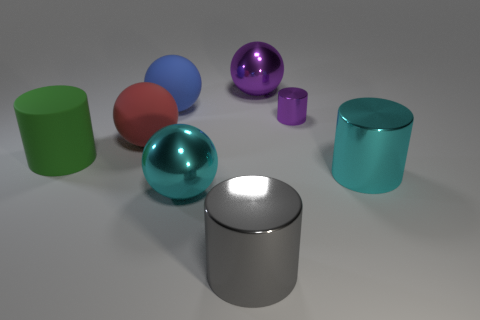Is the number of large red matte things that are in front of the large blue matte object the same as the number of purple metal objects in front of the large purple shiny sphere?
Ensure brevity in your answer.  Yes. Is there any other thing that has the same size as the purple metal cylinder?
Keep it short and to the point. No. What is the material of the other tiny object that is the same shape as the green object?
Your answer should be very brief. Metal. There is a object in front of the shiny sphere that is in front of the purple shiny sphere; are there any big matte objects that are on the left side of it?
Ensure brevity in your answer.  Yes. Do the big cyan thing left of the gray cylinder and the large metallic thing behind the large cyan cylinder have the same shape?
Provide a short and direct response. Yes. Are there more cyan metallic things left of the tiny purple thing than brown rubber cylinders?
Provide a succinct answer. Yes. How many objects are tiny purple rubber balls or large gray cylinders?
Offer a terse response. 1. The matte cylinder has what color?
Your answer should be very brief. Green. How many other objects are there of the same color as the large rubber cylinder?
Your answer should be compact. 0. There is a blue matte sphere; are there any cyan shiny cylinders left of it?
Provide a short and direct response. No. 